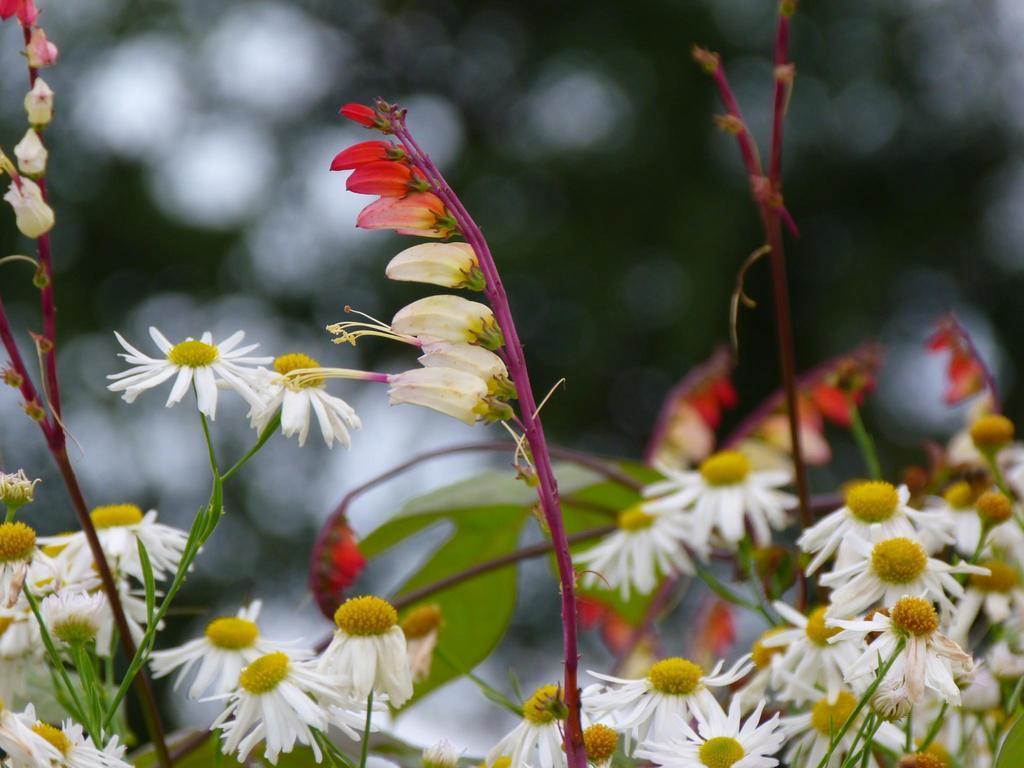Please provide a concise description of this image. In this picture we can see few flowers and plants. 